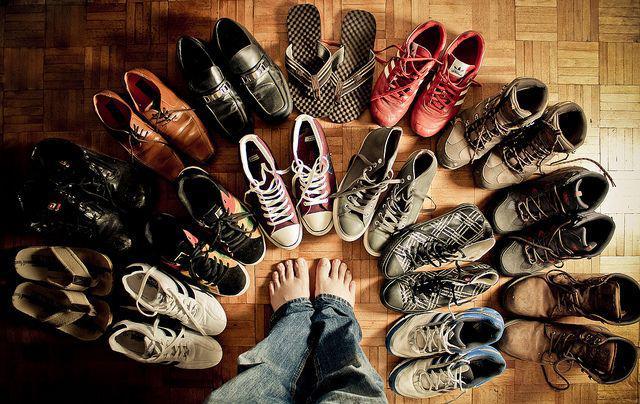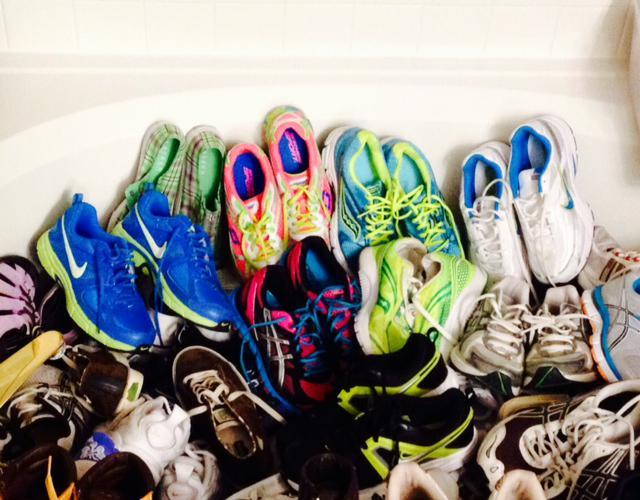The first image is the image on the left, the second image is the image on the right. Analyze the images presented: Is the assertion "There are fifteen pairs of shoes in the left image." valid? Answer yes or no. Yes. The first image is the image on the left, the second image is the image on the right. Evaluate the accuracy of this statement regarding the images: "The left image shows at least a dozen shoe pairs arranged on a wood floor, and the right image shows a messy pile of sneakers.". Is it true? Answer yes or no. Yes. 